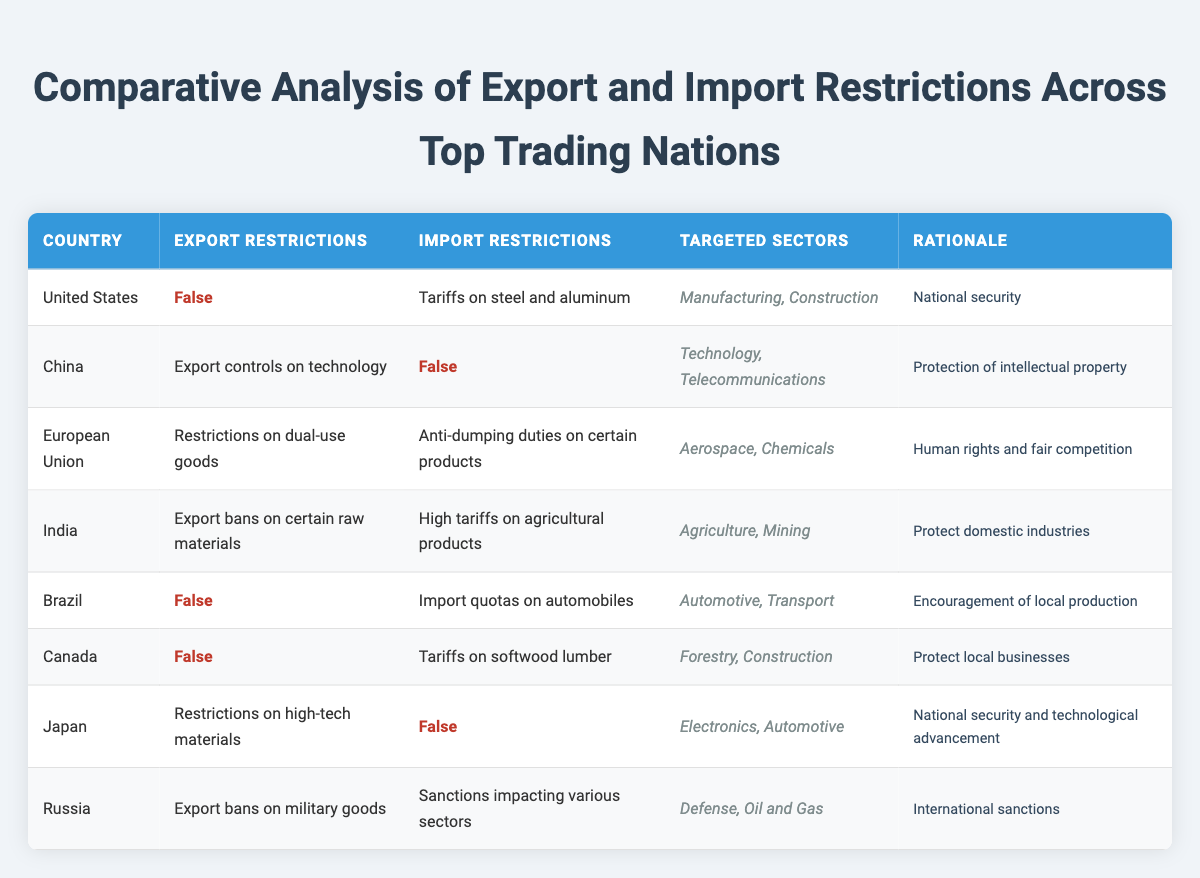What export restrictions does the United States have? According to the table, the United States does not have any export restrictions, as indicated by "False" in the export restrictions column.
Answer: False Which country imposes anti-dumping duties on imports? The European Union enforces anti-dumping duties on certain products, as stated in the import restrictions column for this country.
Answer: European Union How many countries have export restrictions related to national security? There are two countries— the United States (with tariffs on steel and aluminum) and Japan (with restrictions on high-tech materials)— that list national security as a rationale, leading to a total of two.
Answer: 2 Is China subject to import restrictions? The table indicates that China has no import restrictions, labeled as "False" in the import restrictions column.
Answer: False Which nation has the most diverse targeted sectors for export restrictions? Looking at the targeted sectors the countries focus on, China has technology and telecommunications, while India has agriculture and mining. Since we see a variety of sectors across multiple countries, we find that Russia spans defense and oil and gas, despite export restrictions being focused. Hence, various countries have sectors but Russia seems to present two separate domains as opposed to specialization.
Answer: Russia How many countries have both export and import restrictions? By analyzing the table, we can see that the European Union, India, and Russia all have restrictions on both exports and imports. This gives us a total of three countries.
Answer: 3 What is the common rationale for export restrictions imposed by India? The rationale mentioned for India's export restrictions is protection of domestic industries, which is clearly specified in the last column of the table.
Answer: Protect domestic industries Which targeted sectors are affected by Brazil's import restrictions? Brazil has import quotas specifically targeted at sectors associated with automotive and transport, as detailed in the table.
Answer: Automotive, Transport What is the rationale behind import restrictions by the European Union? The rationale for the European Union's import restrictions is human rights and fair competition, expressed in the last column of the table.
Answer: Human rights and fair competition 